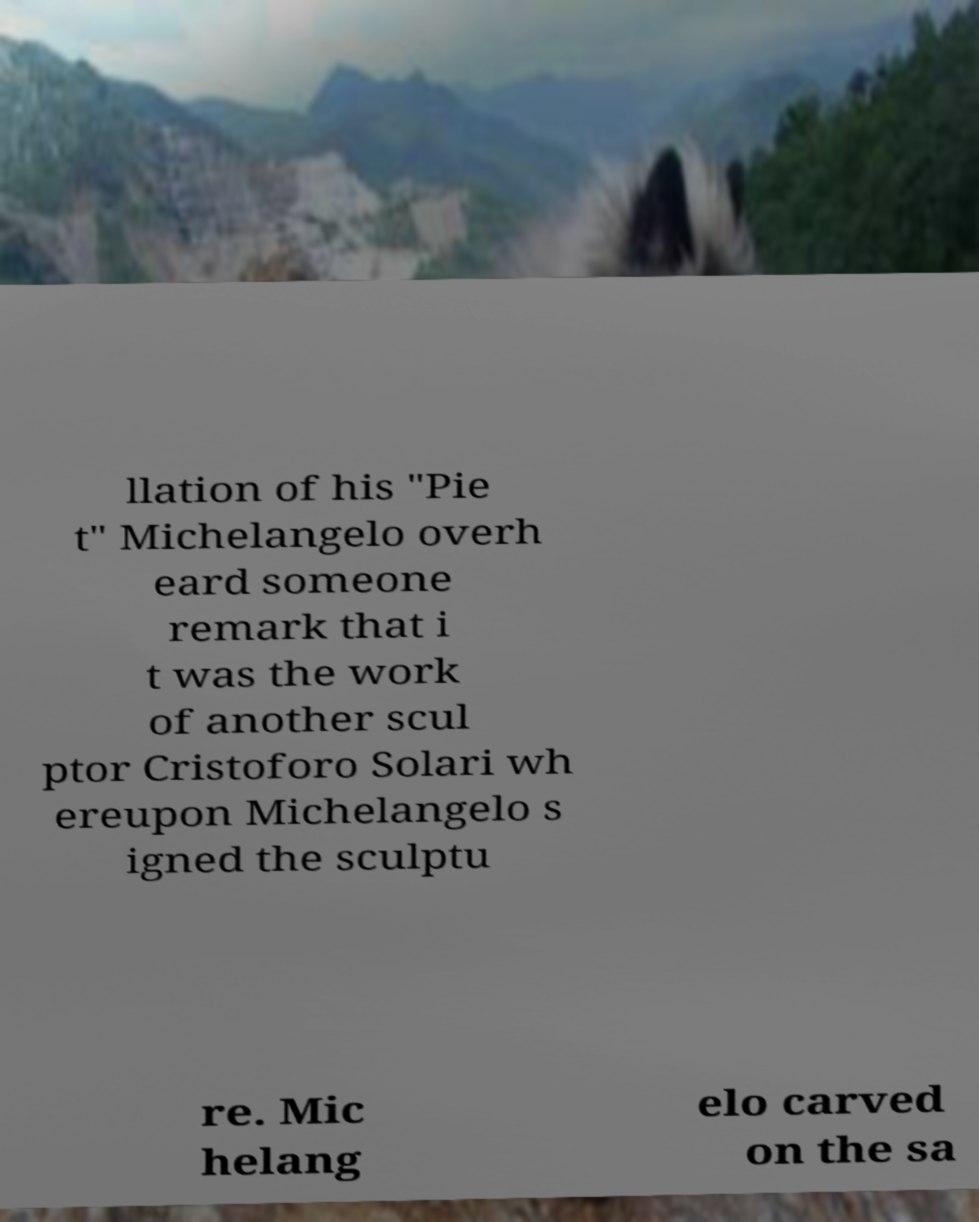Can you read and provide the text displayed in the image?This photo seems to have some interesting text. Can you extract and type it out for me? llation of his "Pie t" Michelangelo overh eard someone remark that i t was the work of another scul ptor Cristoforo Solari wh ereupon Michelangelo s igned the sculptu re. Mic helang elo carved on the sa 